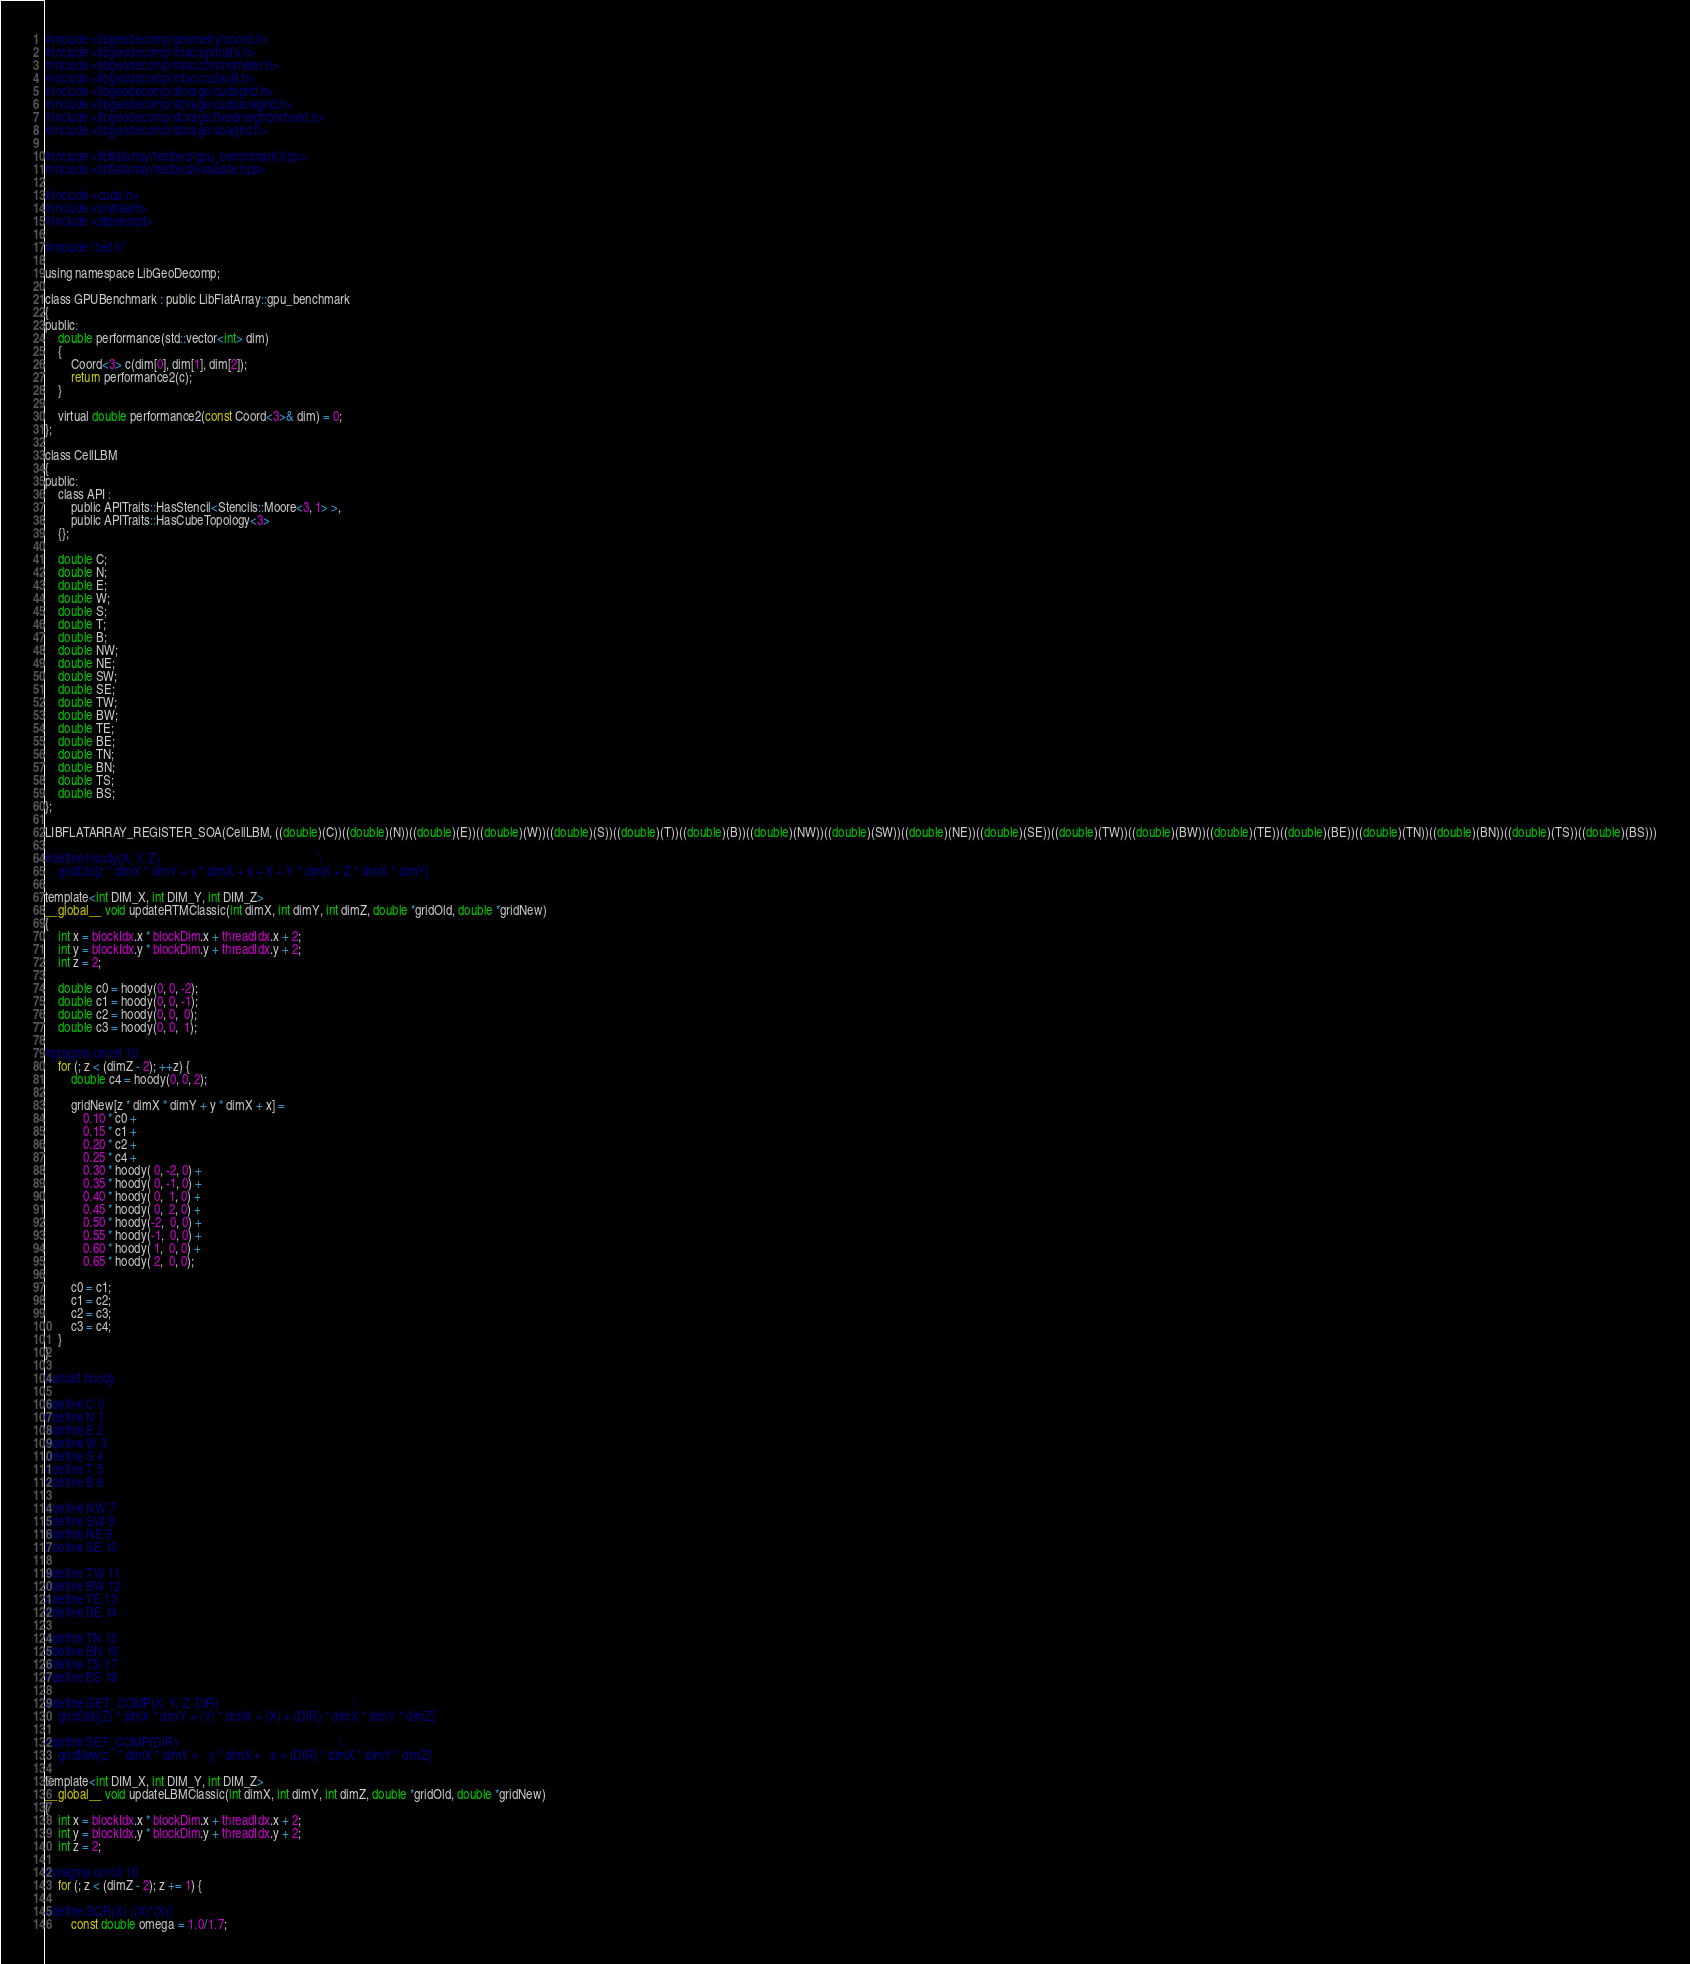Convert code to text. <code><loc_0><loc_0><loc_500><loc_500><_Cuda_>#include <libgeodecomp/geometry/coord.h>
#include <libgeodecomp/misc/apitraits.h>
#include <libgeodecomp/misc/chronometer.h>
#include <libgeodecomp/misc/cudautil.h>
#include <libgeodecomp/storage/cudagrid.h>
#include <libgeodecomp/storage/cudasoagrid.h>
#include <libgeodecomp/storage/fixedneighborhood.h>
#include <libgeodecomp/storage/soagrid.h>

#include <libflatarray/testbed/gpu_benchmark.hpp>
#include <libflatarray/testbed/evaluate.hpp>

#include <cuda.h>
#include <iostream>
#include <stdexcept>

#include "cell.h"

using namespace LibGeoDecomp;

class GPUBenchmark : public LibFlatArray::gpu_benchmark
{
public:
    double performance(std::vector<int> dim)
    {
        Coord<3> c(dim[0], dim[1], dim[2]);
        return performance2(c);
    }

    virtual double performance2(const Coord<3>& dim) = 0;
};

class CellLBM
{
public:
    class API :
        public APITraits::HasStencil<Stencils::Moore<3, 1> >,
        public APITraits::HasCubeTopology<3>
    {};

    double C;
    double N;
    double E;
    double W;
    double S;
    double T;
    double B;
    double NW;
    double NE;
    double SW;
    double SE;
    double TW;
    double BW;
    double TE;
    double BE;
    double TN;
    double BN;
    double TS;
    double BS;
};

LIBFLATARRAY_REGISTER_SOA(CellLBM, ((double)(C))((double)(N))((double)(E))((double)(W))((double)(S))((double)(T))((double)(B))((double)(NW))((double)(SW))((double)(NE))((double)(SE))((double)(TW))((double)(BW))((double)(TE))((double)(BE))((double)(TN))((double)(BN))((double)(TS))((double)(BS)))

#define hoody(X, Y, Z)                                                  \
    gridOld[z * dimX * dimY + y * dimX + x + X + Y * dimX + Z * dimX * dimY]

template<int DIM_X, int DIM_Y, int DIM_Z>
__global__ void updateRTMClassic(int dimX, int dimY, int dimZ, double *gridOld, double *gridNew)
{
    int x = blockIdx.x * blockDim.x + threadIdx.x + 2;
    int y = blockIdx.y * blockDim.y + threadIdx.y + 2;
    int z = 2;

    double c0 = hoody(0, 0, -2);
    double c1 = hoody(0, 0, -1);
    double c2 = hoody(0, 0,  0);
    double c3 = hoody(0, 0,  1);

#pragma unroll 10
    for (; z < (dimZ - 2); ++z) {
        double c4 = hoody(0, 0, 2);

        gridNew[z * dimX * dimY + y * dimX + x] =
            0.10 * c0 +
            0.15 * c1 +
            0.20 * c2 +
            0.25 * c4 +
            0.30 * hoody( 0, -2, 0) +
            0.35 * hoody( 0, -1, 0) +
            0.40 * hoody( 0,  1, 0) +
            0.45 * hoody( 0,  2, 0) +
            0.50 * hoody(-2,  0, 0) +
            0.55 * hoody(-1,  0, 0) +
            0.60 * hoody( 1,  0, 0) +
            0.65 * hoody( 2,  0, 0);

        c0 = c1;
        c1 = c2;
        c2 = c3;
        c3 = c4;
    }
}

#undef hoody

#define C 0
#define N 1
#define E 2
#define W 3
#define S 4
#define T 5
#define B 6

#define NW 7
#define SW 8
#define NE 9
#define SE 10

#define TW 11
#define BW 12
#define TE 13
#define BE 14

#define TN 15
#define BN 16
#define TS 17
#define BS 18

#define GET_COMP(X, Y, Z, DIR)                                          \
    gridOld[(Z) * dimX * dimY + (Y) * dimX + (X) + (DIR) * dimX * dimY * dimZ]

#define SET_COMP(DIR)                                                   \
    gridNew[z   * dimX * dimY +   y * dimX +   x + (DIR) * dimX * dimY * dimZ]

template<int DIM_X, int DIM_Y, int DIM_Z>
__global__ void updateLBMClassic(int dimX, int dimY, int dimZ, double *gridOld, double *gridNew)
{
    int x = blockIdx.x * blockDim.x + threadIdx.x + 2;
    int y = blockIdx.y * blockDim.y + threadIdx.y + 2;
    int z = 2;

#pragma unroll 10
    for (; z < (dimZ - 2); z += 1) {

#define SQR(X) ((X)*(X))
        const double omega = 1.0/1.7;</code> 